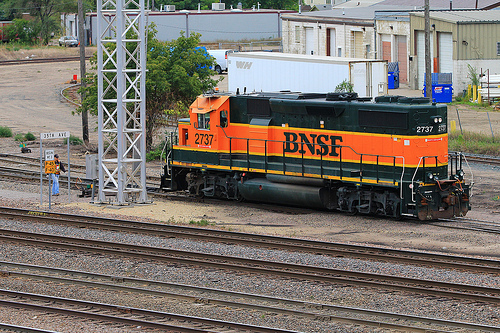How many trains are in the picture? 1 